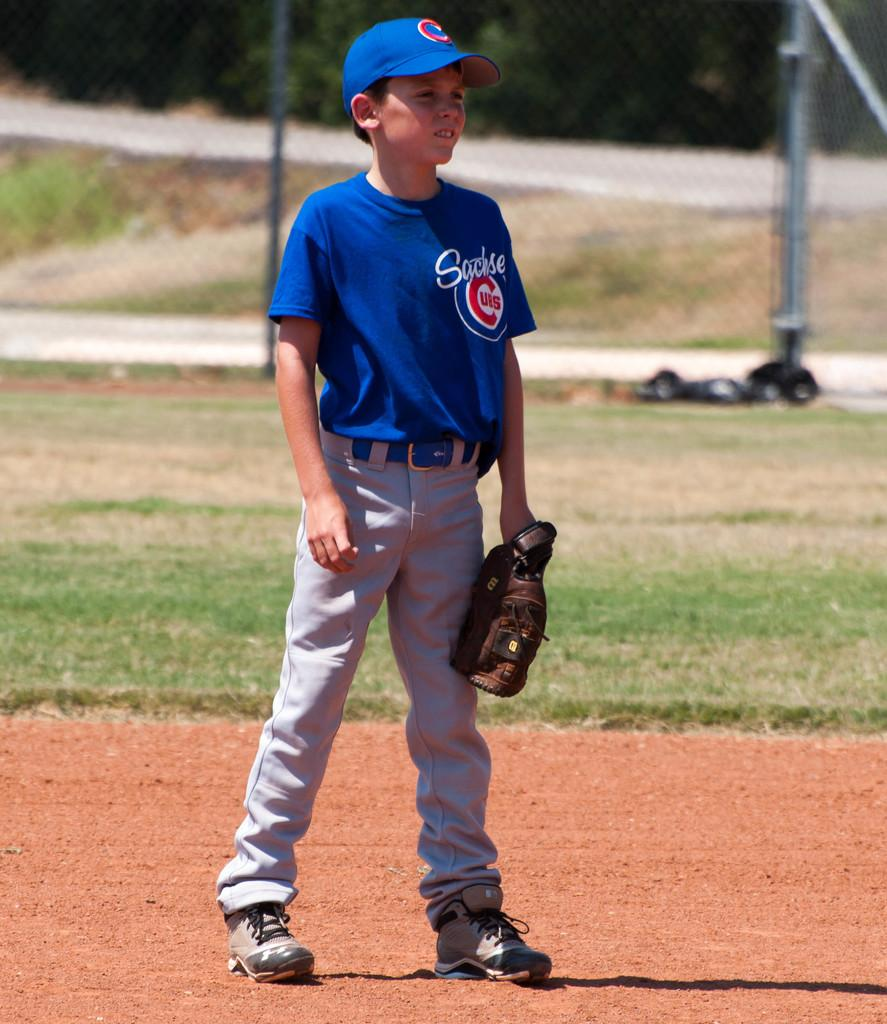Provide a one-sentence caption for the provided image. a boy catcher playing baseball with a Sachse Cubs uniform on. 